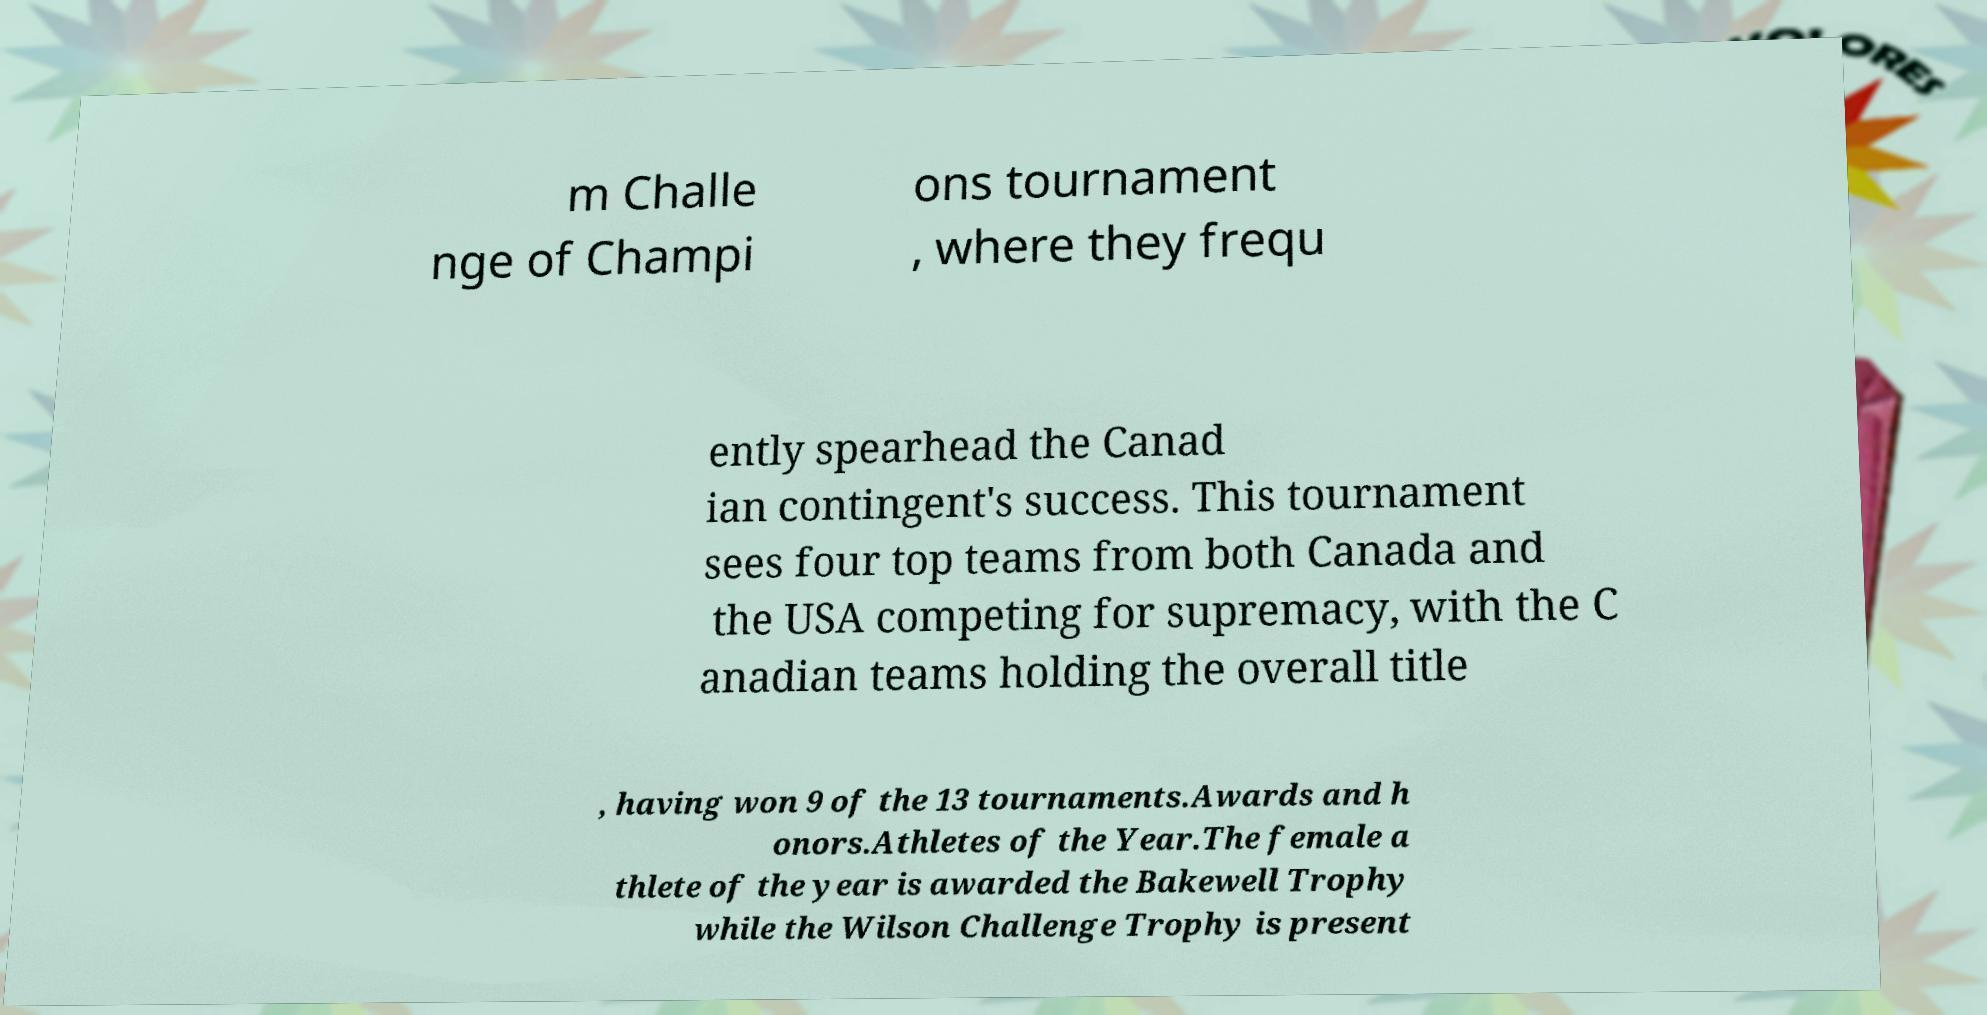Can you read and provide the text displayed in the image?This photo seems to have some interesting text. Can you extract and type it out for me? m Challe nge of Champi ons tournament , where they frequ ently spearhead the Canad ian contingent's success. This tournament sees four top teams from both Canada and the USA competing for supremacy, with the C anadian teams holding the overall title , having won 9 of the 13 tournaments.Awards and h onors.Athletes of the Year.The female a thlete of the year is awarded the Bakewell Trophy while the Wilson Challenge Trophy is present 